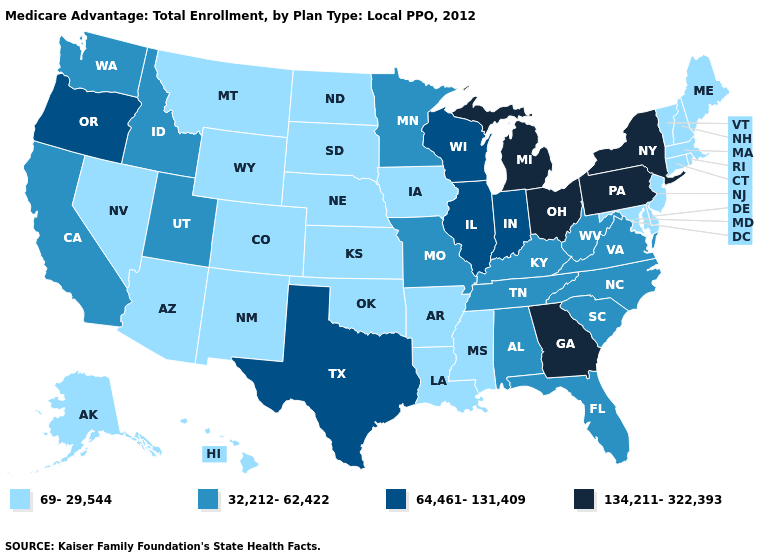Which states hav the highest value in the West?
Short answer required. Oregon. What is the value of Arizona?
Be succinct. 69-29,544. What is the value of Hawaii?
Quick response, please. 69-29,544. What is the highest value in the USA?
Answer briefly. 134,211-322,393. Is the legend a continuous bar?
Short answer required. No. Does the first symbol in the legend represent the smallest category?
Concise answer only. Yes. Does New York have the highest value in the Northeast?
Give a very brief answer. Yes. What is the value of Maine?
Give a very brief answer. 69-29,544. Does Ohio have the highest value in the MidWest?
Write a very short answer. Yes. What is the value of Nebraska?
Keep it brief. 69-29,544. Which states have the highest value in the USA?
Write a very short answer. Georgia, Michigan, New York, Ohio, Pennsylvania. What is the value of Montana?
Write a very short answer. 69-29,544. Name the states that have a value in the range 64,461-131,409?
Be succinct. Illinois, Indiana, Oregon, Texas, Wisconsin. What is the value of Montana?
Short answer required. 69-29,544. Name the states that have a value in the range 69-29,544?
Concise answer only. Alaska, Arkansas, Arizona, Colorado, Connecticut, Delaware, Hawaii, Iowa, Kansas, Louisiana, Massachusetts, Maryland, Maine, Mississippi, Montana, North Dakota, Nebraska, New Hampshire, New Jersey, New Mexico, Nevada, Oklahoma, Rhode Island, South Dakota, Vermont, Wyoming. 